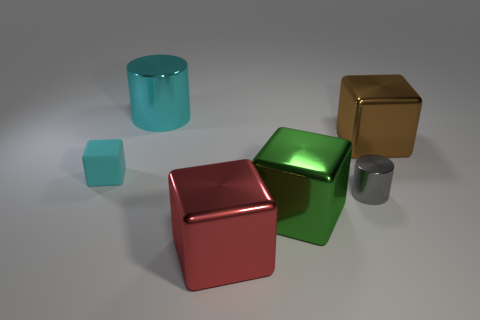Add 4 cyan rubber things. How many objects exist? 10 Subtract all cylinders. How many objects are left? 4 Subtract 0 green balls. How many objects are left? 6 Subtract all large shiny cylinders. Subtract all big cyan things. How many objects are left? 4 Add 1 gray shiny things. How many gray shiny things are left? 2 Add 5 large red cubes. How many large red cubes exist? 6 